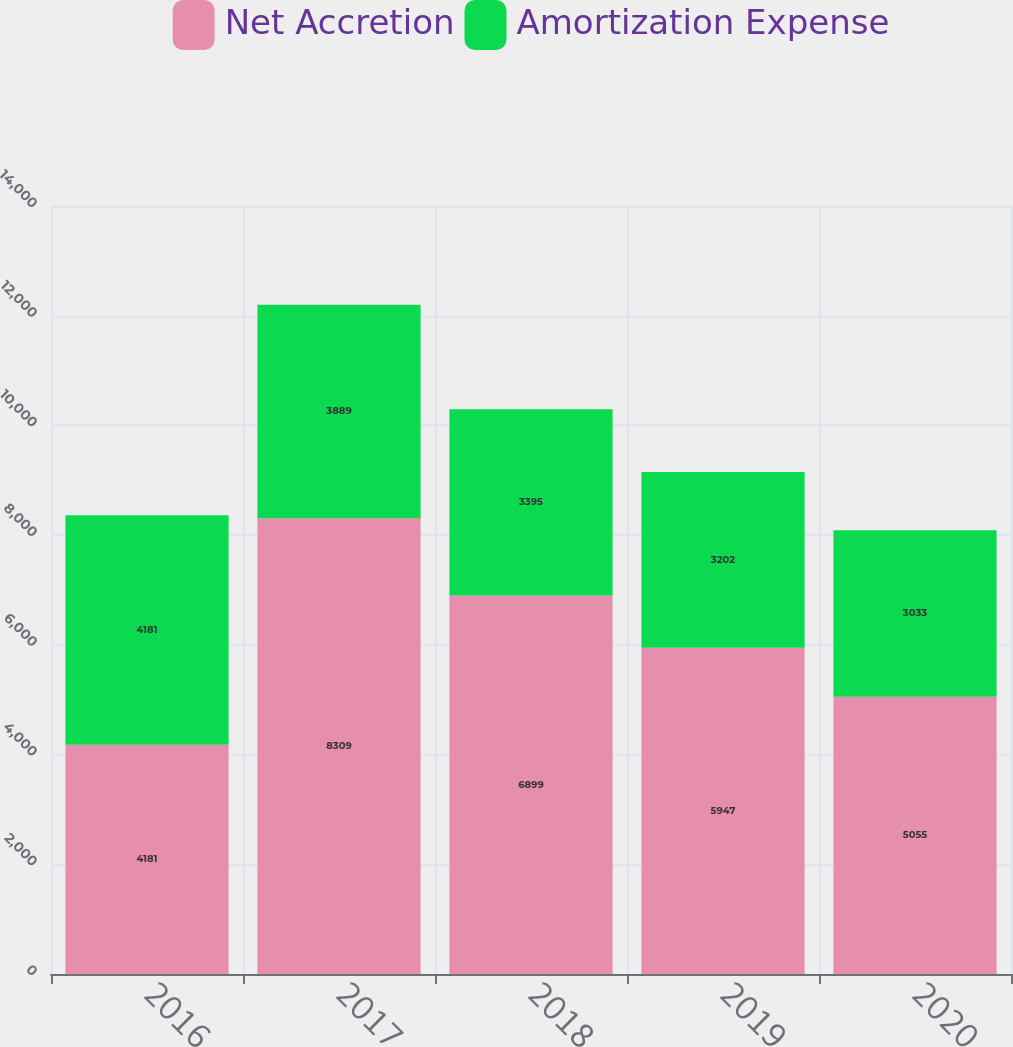<chart> <loc_0><loc_0><loc_500><loc_500><stacked_bar_chart><ecel><fcel>2016<fcel>2017<fcel>2018<fcel>2019<fcel>2020<nl><fcel>Net Accretion<fcel>4181<fcel>8309<fcel>6899<fcel>5947<fcel>5055<nl><fcel>Amortization Expense<fcel>4181<fcel>3889<fcel>3395<fcel>3202<fcel>3033<nl></chart> 